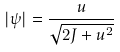<formula> <loc_0><loc_0><loc_500><loc_500>| \psi | = \frac { u } { \sqrt { 2 J + u ^ { 2 } } }</formula> 